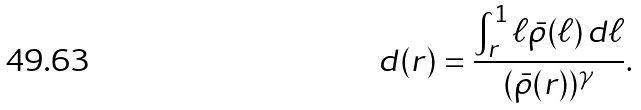<formula> <loc_0><loc_0><loc_500><loc_500>d ( r ) = \frac { \int _ { r } ^ { 1 } \ell \bar { \rho } ( \ell ) \, d \ell } { ( \bar { \rho } ( r ) ) ^ { \gamma } } .</formula> 